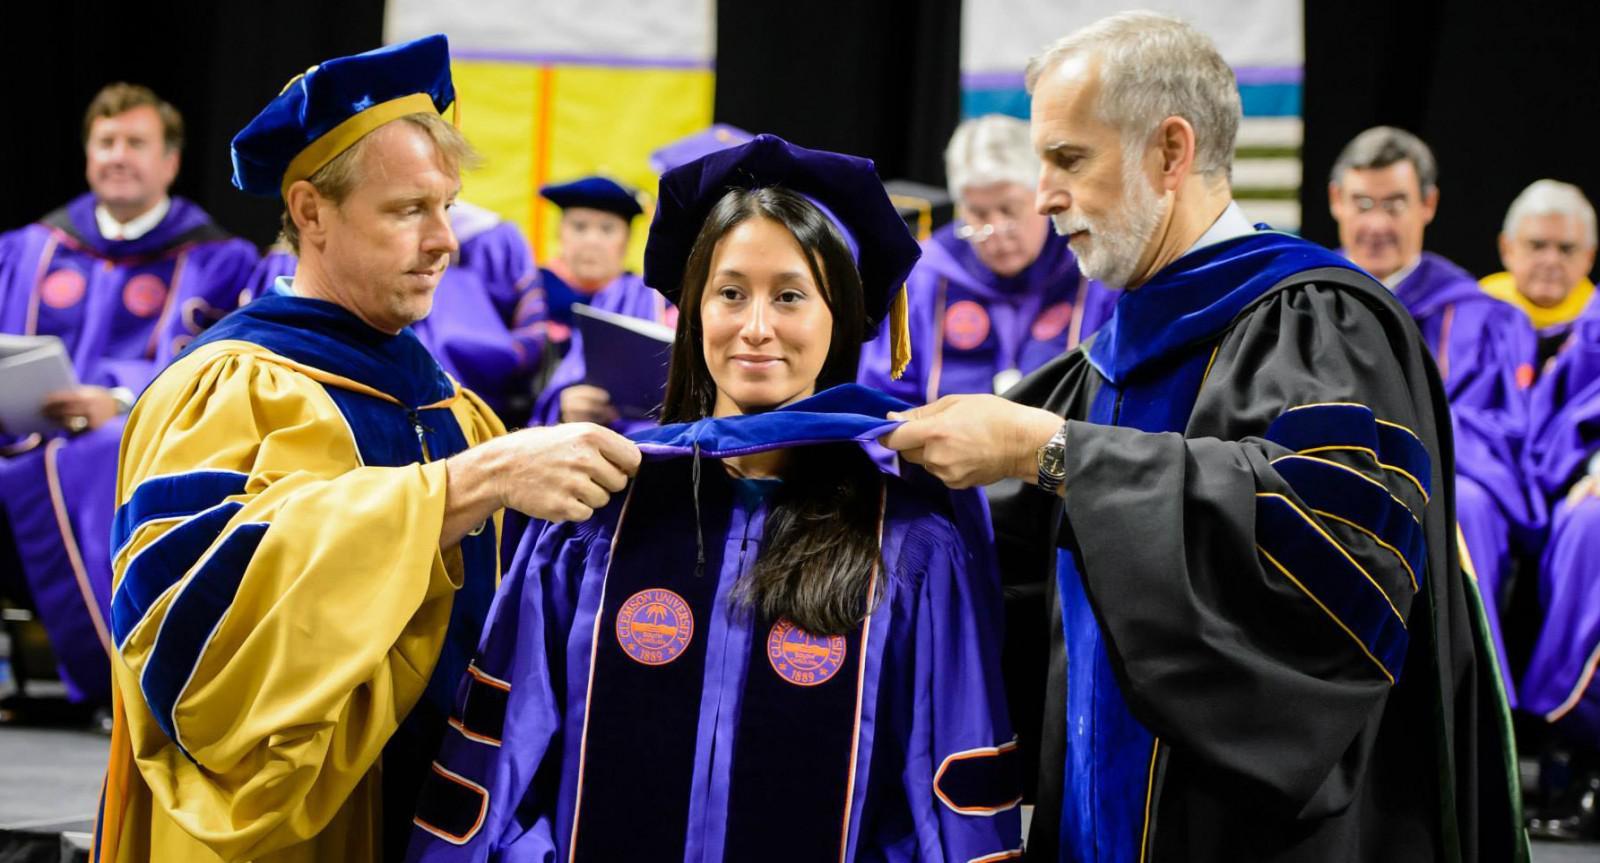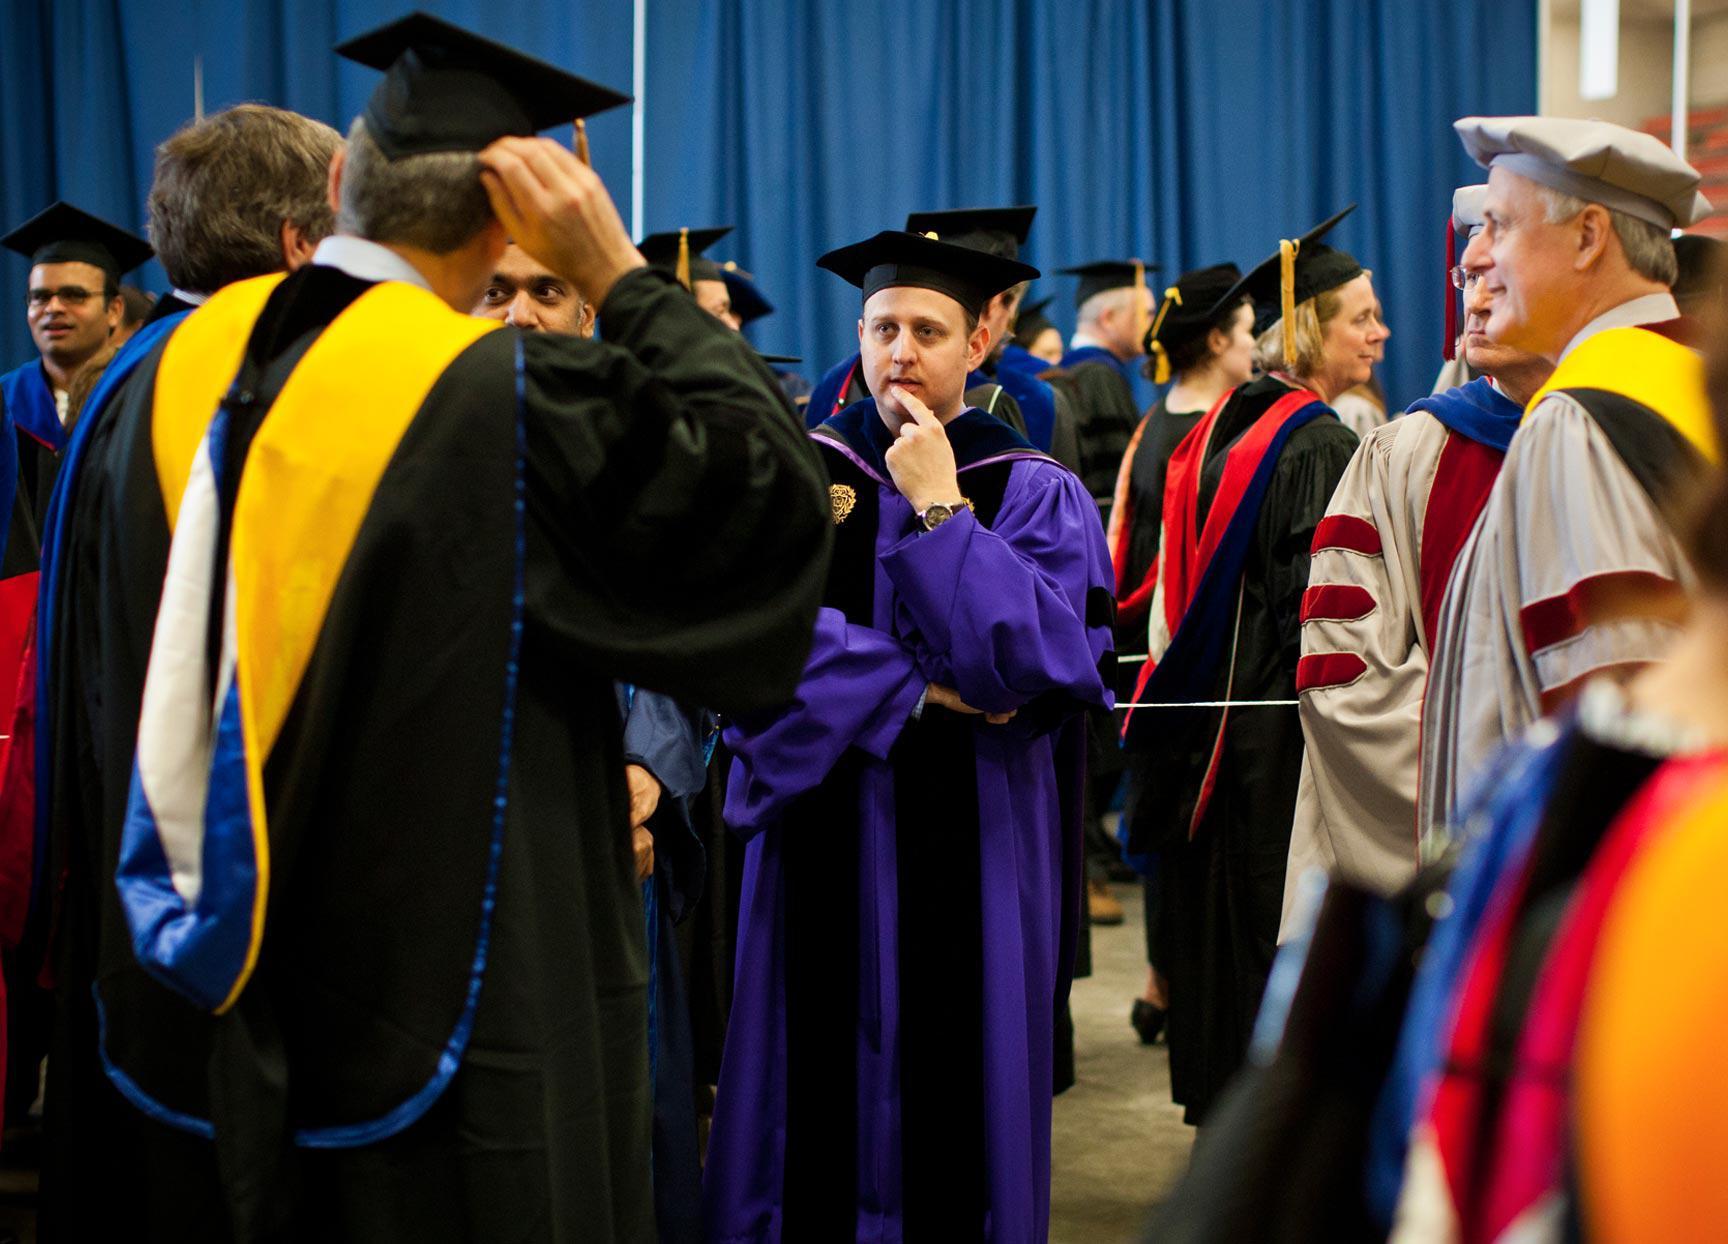The first image is the image on the left, the second image is the image on the right. For the images displayed, is the sentence "The left image contains no more than three graduation students." factually correct? Answer yes or no. No. The first image is the image on the left, the second image is the image on the right. Given the left and right images, does the statement "An image includes in the foreground a black bearded man in a black robe and tasseled square cap near a white man in a gray robe and beret-type hat." hold true? Answer yes or no. No. 